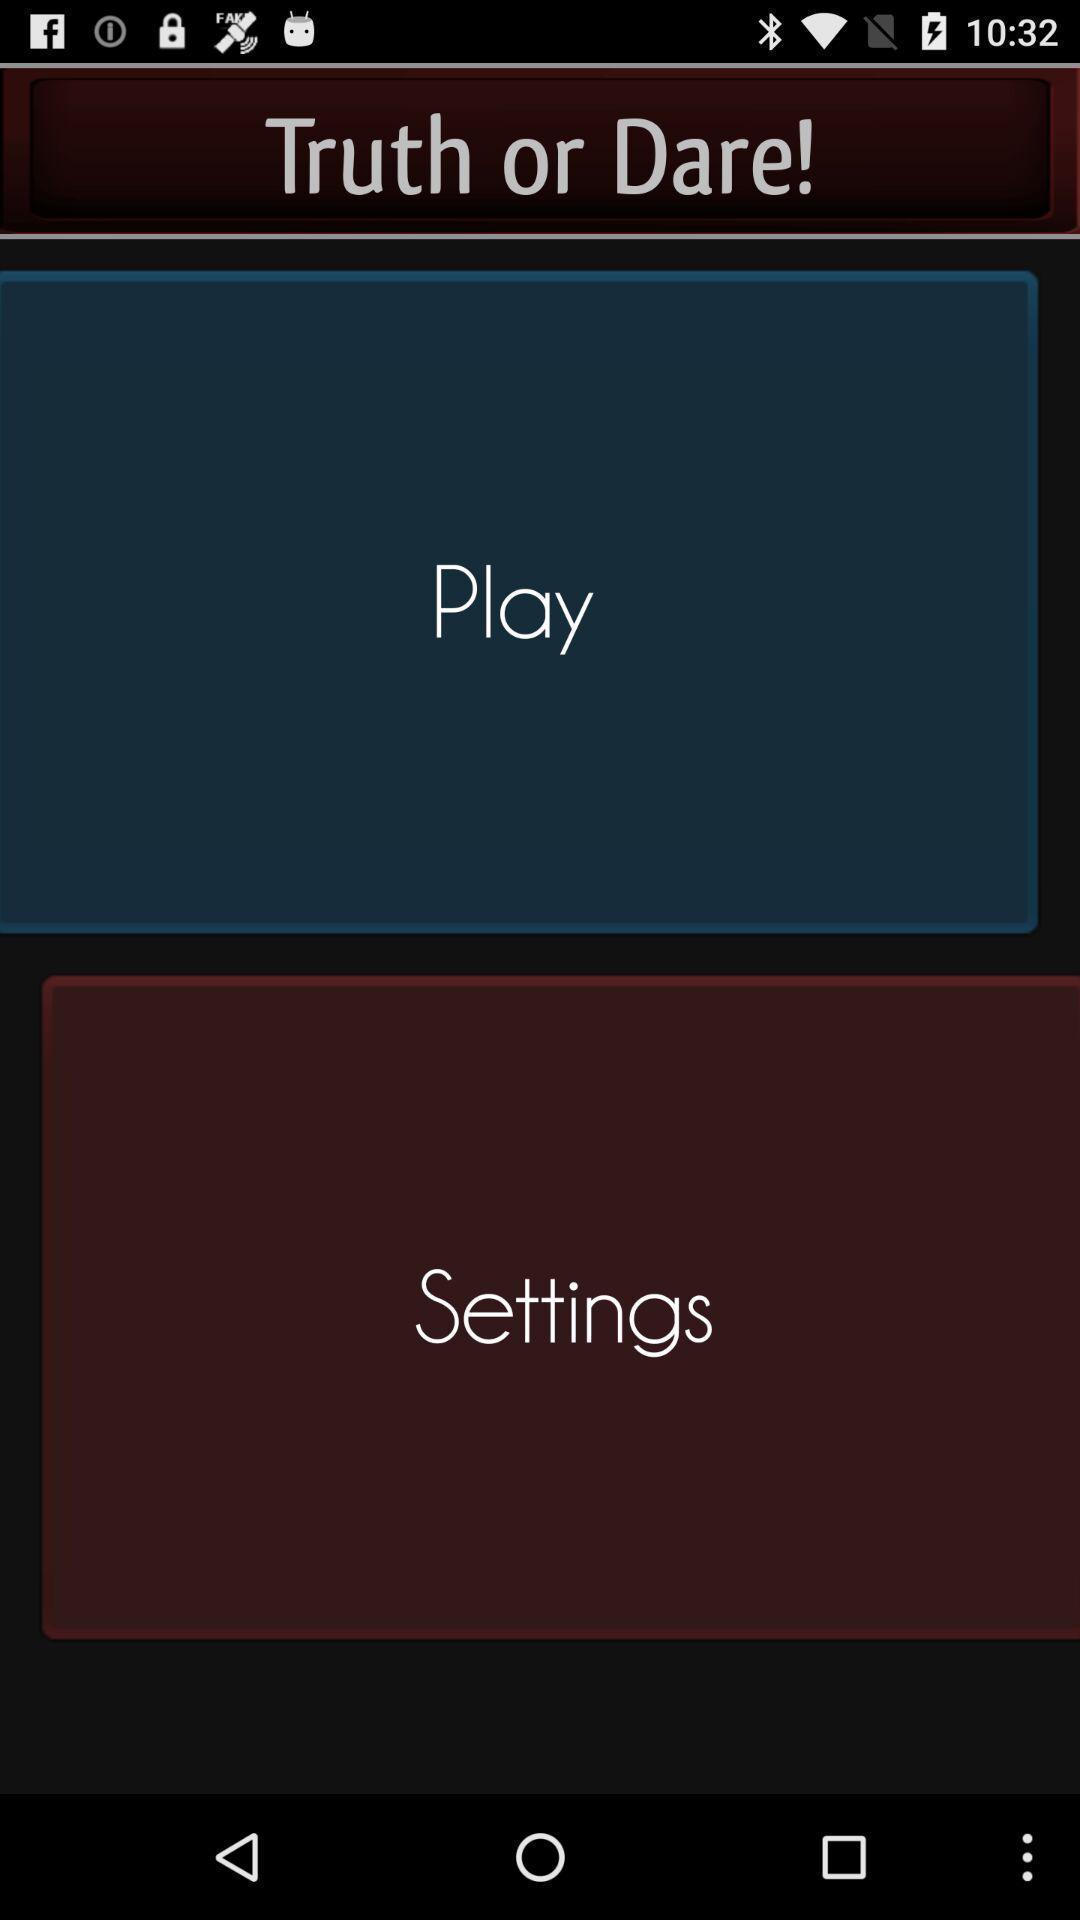Explain what's happening in this screen capture. Screen page of a game application. 